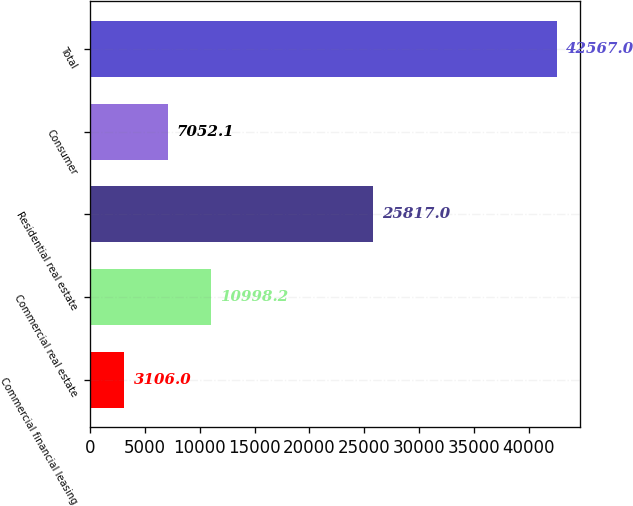<chart> <loc_0><loc_0><loc_500><loc_500><bar_chart><fcel>Commercial financial leasing<fcel>Commercial real estate<fcel>Residential real estate<fcel>Consumer<fcel>Total<nl><fcel>3106<fcel>10998.2<fcel>25817<fcel>7052.1<fcel>42567<nl></chart> 